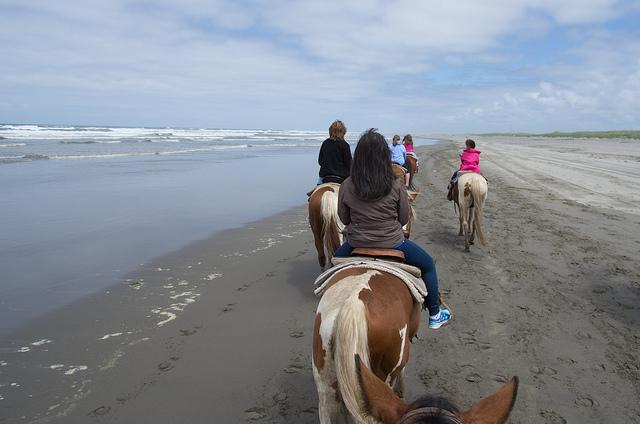What color is the horse on the right?
Be succinct. White. Is the woman looking in the direction she is traveling?
Be succinct. Yes. How many people do you see?
Short answer required. 5. What kind of horses are these?
Write a very short answer. Paint. 